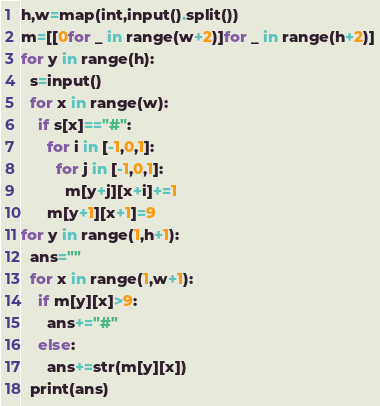<code> <loc_0><loc_0><loc_500><loc_500><_Python_>h,w=map(int,input().split())
m=[[0for _ in range(w+2)]for _ in range(h+2)]
for y in range(h):
  s=input()
  for x in range(w):
    if s[x]=="#":
      for i in [-1,0,1]:
        for j in [-1,0,1]:
          m[y+j][x+i]+=1
      m[y+1][x+1]=9
for y in range(1,h+1):
  ans=""
  for x in range(1,w+1):
    if m[y][x]>9:
      ans+="#"
    else:
      ans+=str(m[y][x])
  print(ans)</code> 